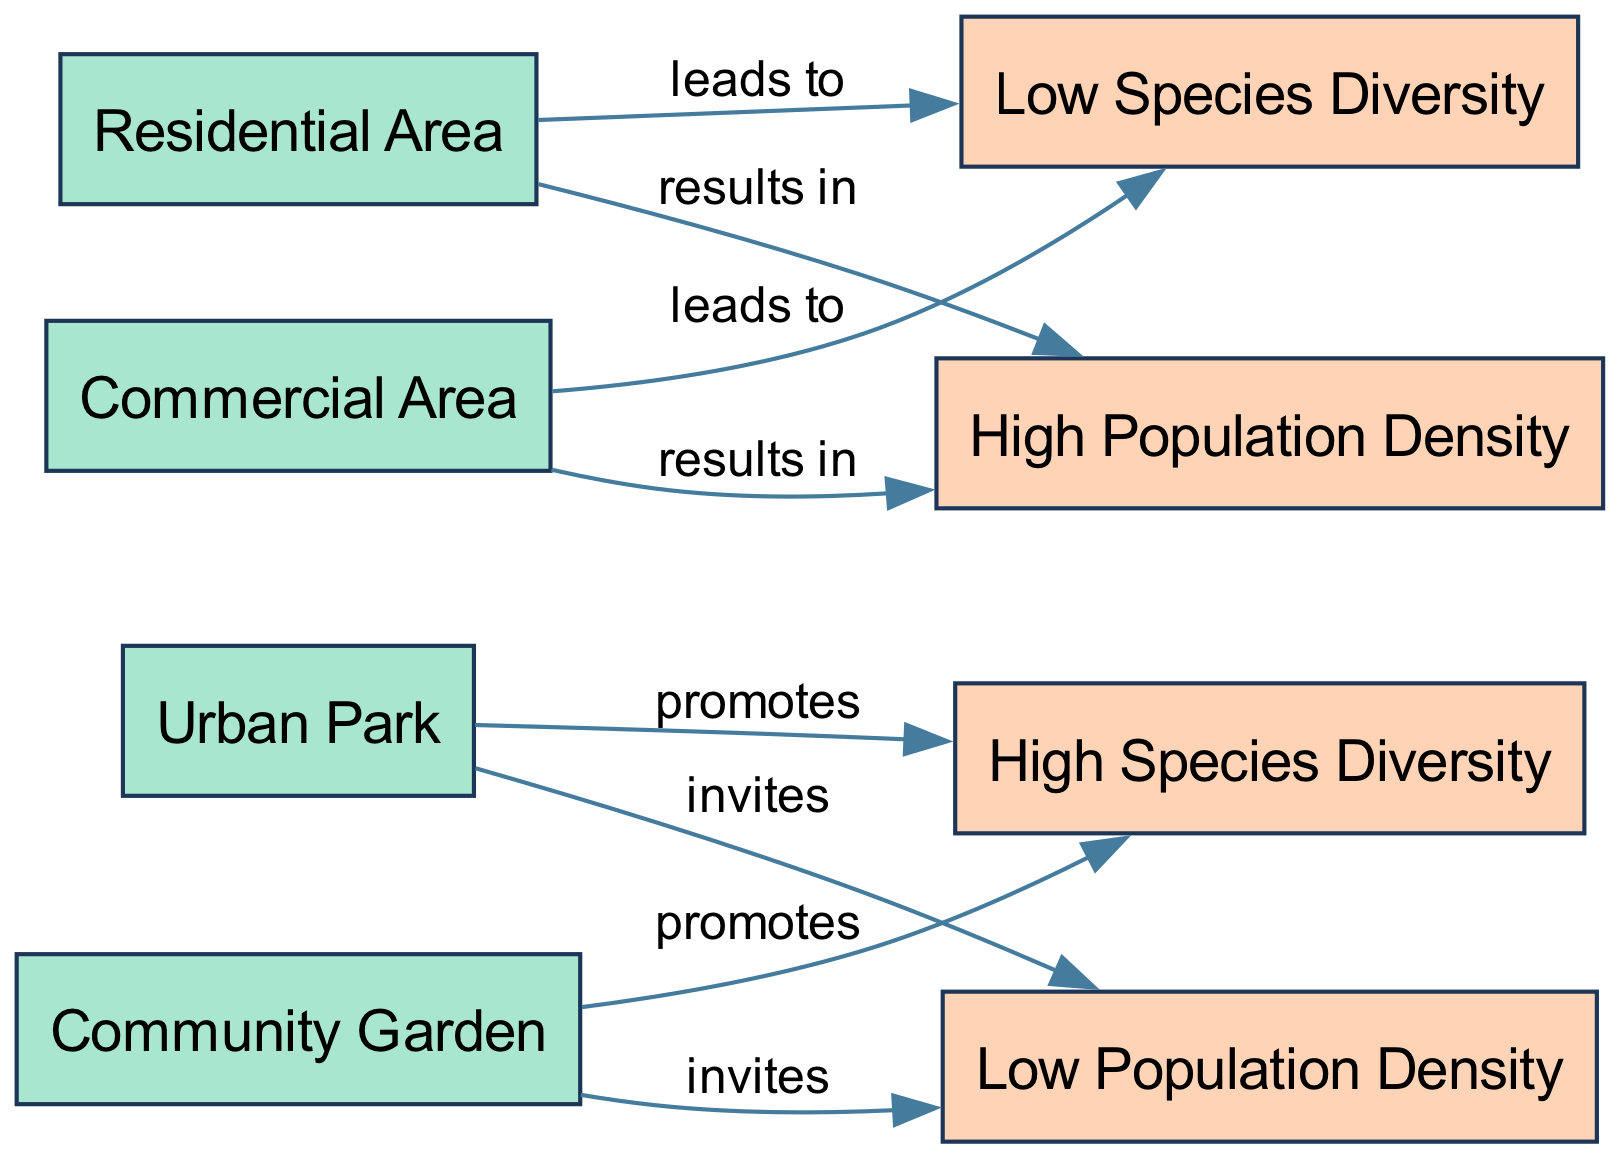What feature promotes high species diversity in cities? The diagram shows that both "Urban Park" and "Community Garden" promote high species diversity. By following the edges labeled "promotes" from these features, we can identify their positive impact on biodiversity.
Answer: Urban Park, Community Garden How many features are shown in the diagram? The diagram contains 5 features, including the "Urban Park," "Community Garden," "Residential Area," and "Commercial Area." Counting these specific nodes gives us the total number of features.
Answer: 5 What outcome is associated with residential areas? The diagram shows that residential areas lead to low species diversity and result in high population density. Following the edge labeled "leads to" confirms this connection.
Answer: Low Species Diversity, High Population Density What type of areas invite low population density? According to the diagram, both urban parks and community gardens invite low population density. The edges labeled "invites" point to the associated outcomes showing the positive effect of these features.
Answer: Urban Park, Community Garden How many edges are there in total in the diagram? The diagram features 8 edges that connect the nodes, demonstrating the relationships between features and outcomes. By counting all the connecting lines, we determine the total number of edges.
Answer: 8 Which area results in high population density? The diagram indicates that both residential and commercial areas result in high population density. By observing the edges labeled "results in," we can confirm this outcome.
Answer: Residential Area, Commercial Area What does the community garden promote? The diagram clearly states that the "Community Garden" promotes high species diversity. Following the edge labeled "promotes" from the community garden leads to this outcome.
Answer: High Species Diversity What leads to low species diversity? The diagram indicates that both residential and commercial areas lead to low species diversity. This can be confirmed by tracing the edges labeled "leads to" that connect these areas to their outcome.
Answer: Low Species Diversity 